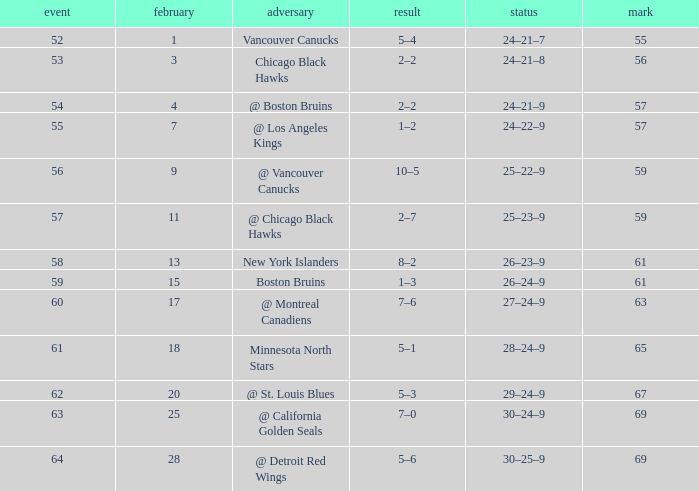Would you be able to parse every entry in this table? {'header': ['event', 'february', 'adversary', 'result', 'status', 'mark'], 'rows': [['52', '1', 'Vancouver Canucks', '5–4', '24–21–7', '55'], ['53', '3', 'Chicago Black Hawks', '2–2', '24–21–8', '56'], ['54', '4', '@ Boston Bruins', '2–2', '24–21–9', '57'], ['55', '7', '@ Los Angeles Kings', '1–2', '24–22–9', '57'], ['56', '9', '@ Vancouver Canucks', '10–5', '25–22–9', '59'], ['57', '11', '@ Chicago Black Hawks', '2–7', '25–23–9', '59'], ['58', '13', 'New York Islanders', '8–2', '26–23–9', '61'], ['59', '15', 'Boston Bruins', '1–3', '26–24–9', '61'], ['60', '17', '@ Montreal Canadiens', '7–6', '27–24–9', '63'], ['61', '18', 'Minnesota North Stars', '5–1', '28–24–9', '65'], ['62', '20', '@ St. Louis Blues', '5–3', '29–24–9', '67'], ['63', '25', '@ California Golden Seals', '7–0', '30–24–9', '69'], ['64', '28', '@ Detroit Red Wings', '5–6', '30–25–9', '69']]} How many february games had a record of 29–24–9? 20.0. 